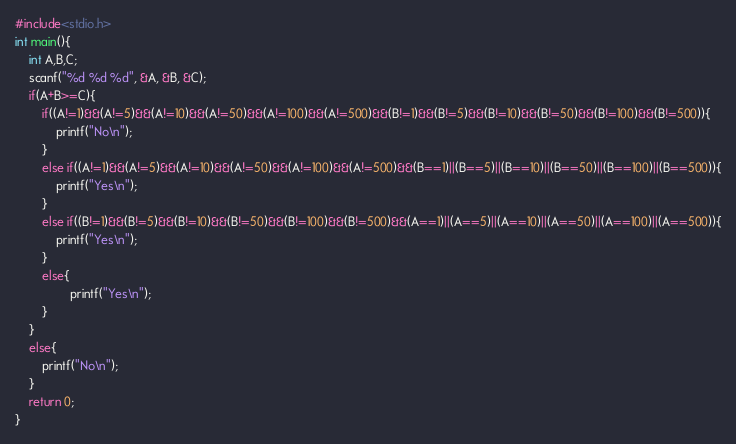<code> <loc_0><loc_0><loc_500><loc_500><_C_>#include<stdio.h>
int main(){
    int A,B,C;
    scanf("%d %d %d", &A, &B, &C);
    if(A+B>=C){
        if((A!=1)&&(A!=5)&&(A!=10)&&(A!=50)&&(A!=100)&&(A!=500)&&(B!=1)&&(B!=5)&&(B!=10)&&(B!=50)&&(B!=100)&&(B!=500)){
            printf("No\n");
        }
        else if((A!=1)&&(A!=5)&&(A!=10)&&(A!=50)&&(A!=100)&&(A!=500)&&(B==1)||(B==5)||(B==10)||(B==50)||(B==100)||(B==500)){
            printf("Yes\n");
        }
        else if((B!=1)&&(B!=5)&&(B!=10)&&(B!=50)&&(B!=100)&&(B!=500)&&(A==1)||(A==5)||(A==10)||(A==50)||(A==100)||(A==500)){
            printf("Yes\n");
        }
        else{
                printf("Yes\n");
        }
    }
    else{
        printf("No\n");
    }
    return 0;
}</code> 